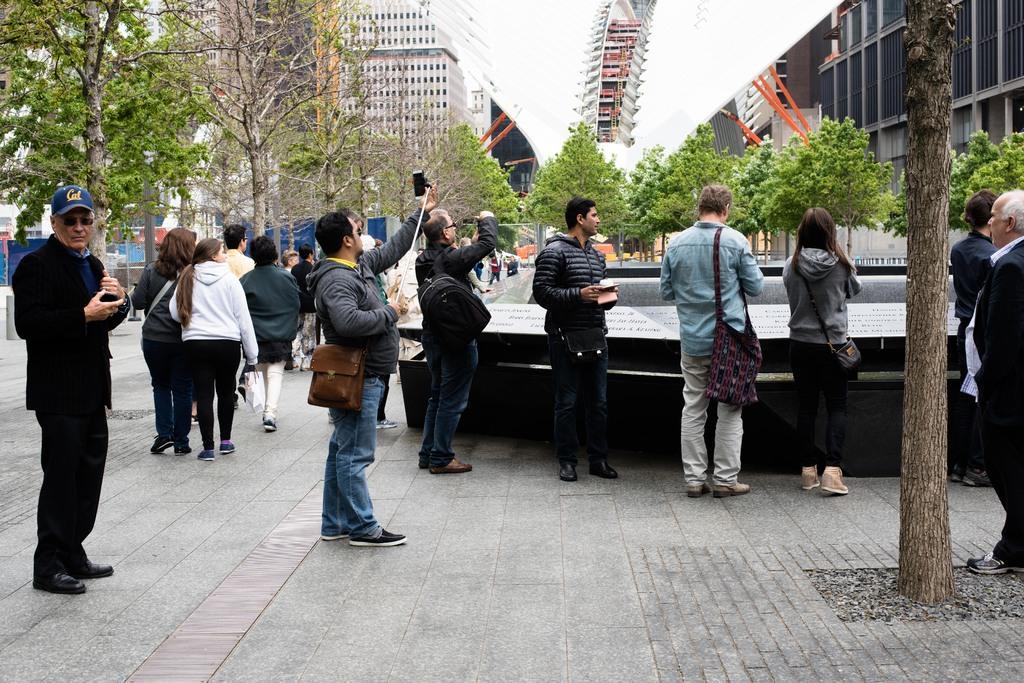Can you describe this image briefly? Here we can see few people standing on the ground and among them few persons are carrying bags on their shoulders. In the background there are trees,buildings,poles,windows and some other objects. 